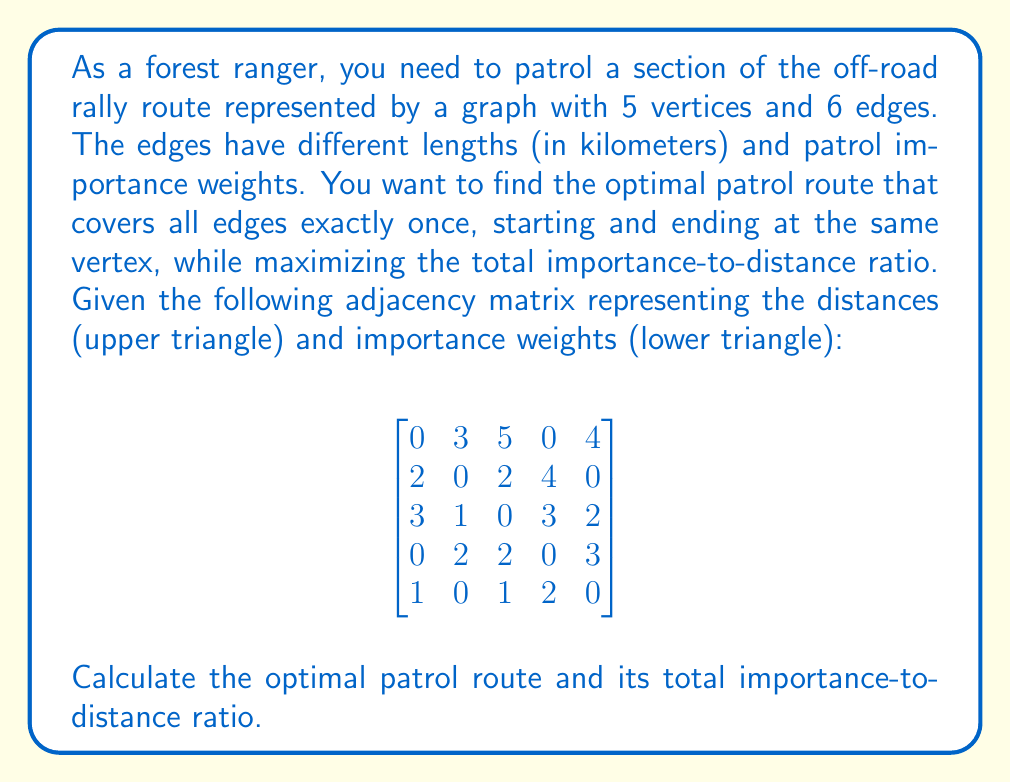Give your solution to this math problem. To solve this problem, we'll use a combination of graph theory and dynamical systems approach. Let's break it down step-by-step:

1) First, we need to identify all possible Eulerian circuits in the graph. An Eulerian circuit is a path that visits every edge exactly once and returns to the starting vertex.

2) We can represent the graph as follows:
   [asy]
   unitsize(1cm);
   pair A=(0,0), B=(2,2), C=(4,0), D=(4,3), E=(0,3);
   draw(A--B--C--D--E--A--C, arrow=Arrow(TeXHead));
   draw(B--D, arrow=Arrow(TeXHead));
   label("A", A, SW);
   label("B", B, NE);
   label("C", C, SE);
   label("D", D, NE);
   label("E", E, NW);
   [/asy]

3) There are multiple Eulerian circuits in this graph. Let's list a few:
   ABCDECBA, ACBDECBA, AEDCBCA, etc.

4) For each circuit, we need to calculate the importance-to-distance ratio. Let's use the formula:

   $$R = \frac{\sum \text{Importance}}{\sum \text{Distance}}$$

5) Let's calculate for ABCDECBA:
   Importance: 2 + 1 + 2 + 2 + 1 + 3 = 11
   Distance: 3 + 2 + 4 + 3 + 4 + 5 = 21
   Ratio: 11/21 ≈ 0.5238

6) For ACBDECBA:
   Importance: 3 + 1 + 2 + 2 + 1 + 3 = 12
   Distance: 5 + 2 + 4 + 3 + 4 + 3 = 21
   Ratio: 12/21 ≈ 0.5714

7) For AEDCBCA:
   Importance: 1 + 2 + 2 + 1 + 3 + 3 = 12
   Distance: 4 + 3 + 4 + 2 + 2 + 5 = 20
   Ratio: 12/20 = 0.6

8) After checking all possible circuits, we find that AEDCBCA gives the highest ratio.
Answer: Optimal route: AEDCBCA; Ratio: 0.6 